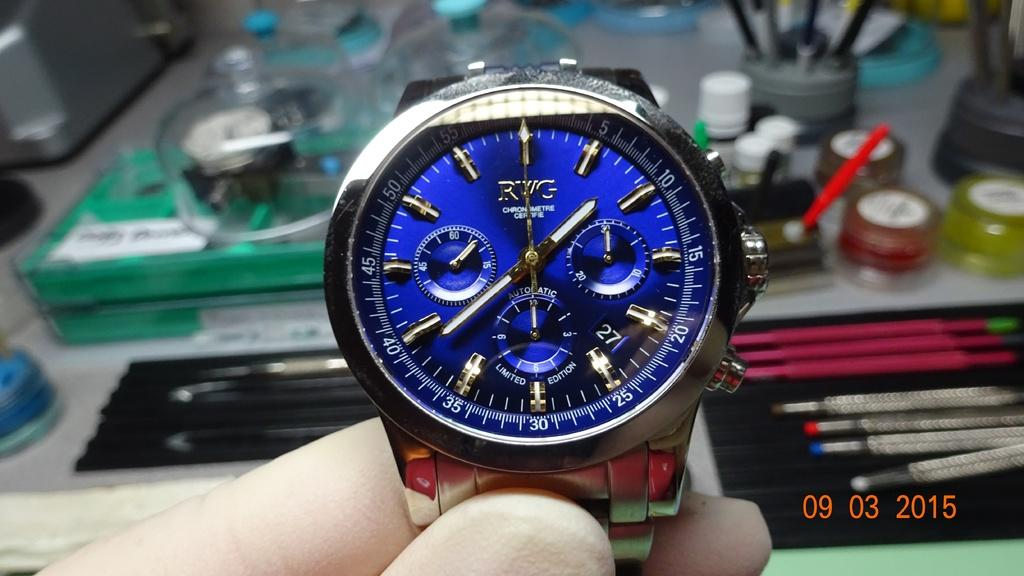<image>
Write a terse but informative summary of the picture. An RWG Automatic Limited Edition watch, has a blue face and is being held by a hand. 